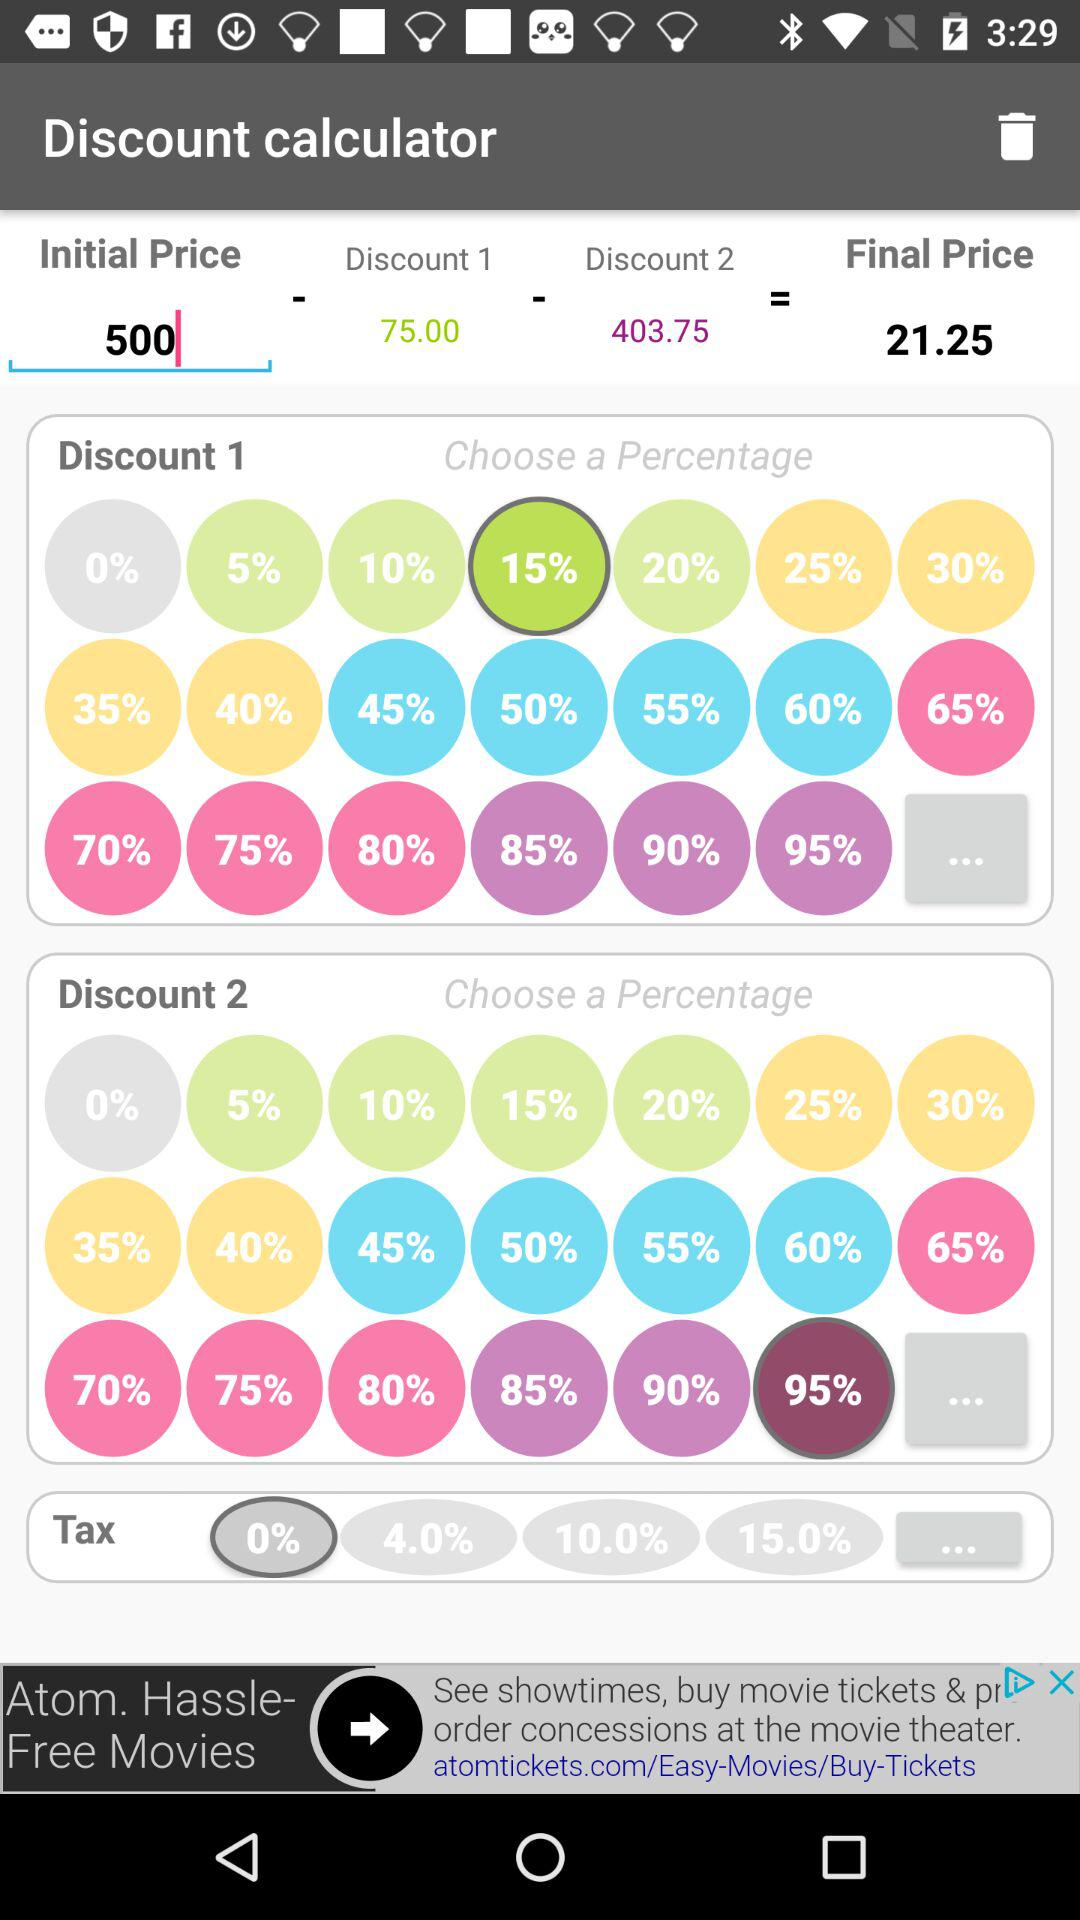What is the value in "Discount 2"? The value in "Discount 2" is 403.75. 